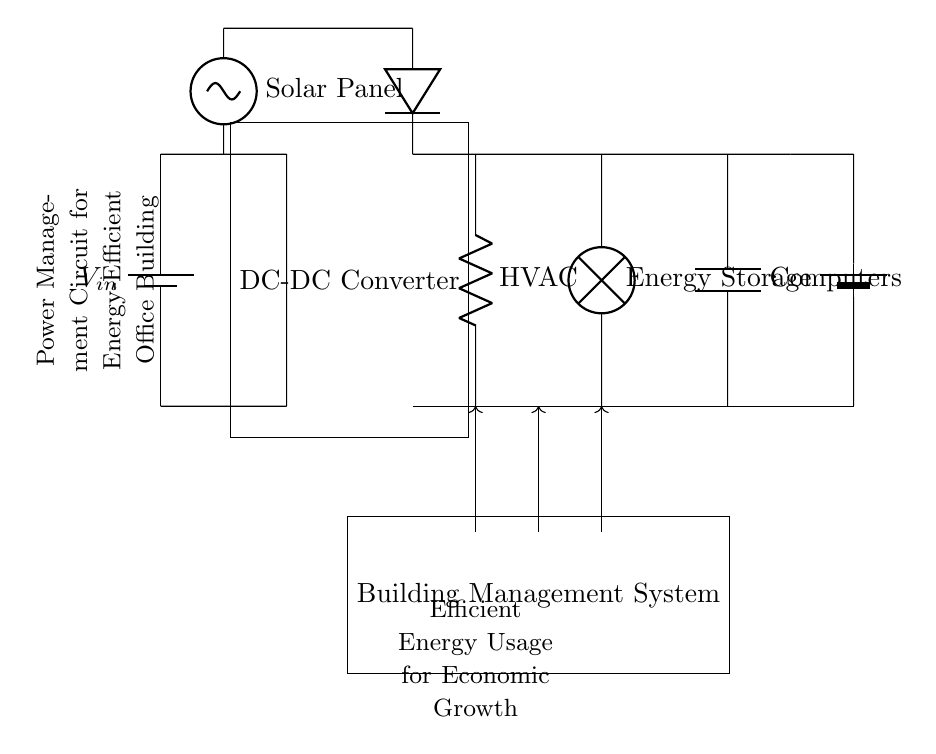What is the main component providing power in this circuit? The main component is the battery, labeled as V_in, which supplies the initial voltage to the circuit.
Answer: battery What is the function of the DC-DC converter in this circuit? The DC-DC converter adjusts the voltage from the battery to the proper levels needed for other components, ensuring efficient energy usage.
Answer: voltage adjustment Which component is responsible for controlling HVAC operations? The component responsible for HVAC operations is the resistor labeled as HVAC, which indicates the electrical load associated with heating, ventilation, and air conditioning.
Answer: resistor How does the energy storage feature work in this circuit? The energy storage is managed by a second battery, labeled Energy Storage, that stores excess energy for later use, particularly from solar input during peak generation times.
Answer: battery What type of renewable energy source is included in this system? The renewable energy source included is the solar panel, which generates electricity from sunlight and is integrated into the power management system.
Answer: solar panel How does the Building Management System interact with other components? The Building Management System directs power to HVAC, lighting, and computer systems through arrows indicating controls, optimizing energy distribution and efficiency.
Answer: control system 